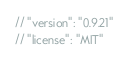<code> <loc_0><loc_0><loc_500><loc_500><_JavaScript_>// "version": "0.9.21"
// "license": "MIT"</code> 